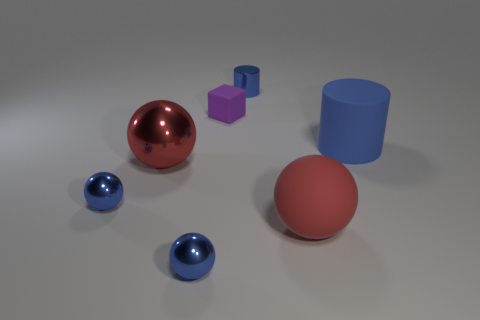There is another red thing that is the same shape as the big red metallic object; what material is it?
Offer a terse response. Rubber. The purple matte thing is what shape?
Provide a short and direct response. Cube. Is the material of the cube the same as the big cylinder?
Offer a very short reply. Yes. Are there the same number of big objects that are behind the purple matte thing and purple matte objects that are to the right of the red matte thing?
Make the answer very short. Yes. Are there any large blue objects that are behind the blue shiny sphere in front of the matte thing in front of the rubber cylinder?
Provide a succinct answer. Yes. Is the rubber cylinder the same size as the blue metallic cylinder?
Offer a very short reply. No. What color is the object that is to the right of the ball that is right of the blue thing that is behind the large cylinder?
Provide a short and direct response. Blue. How many other tiny cylinders are the same color as the metallic cylinder?
Your response must be concise. 0. What number of small things are either purple things or matte things?
Provide a succinct answer. 1. Is there a big matte thing of the same shape as the small rubber object?
Your answer should be compact. No. 